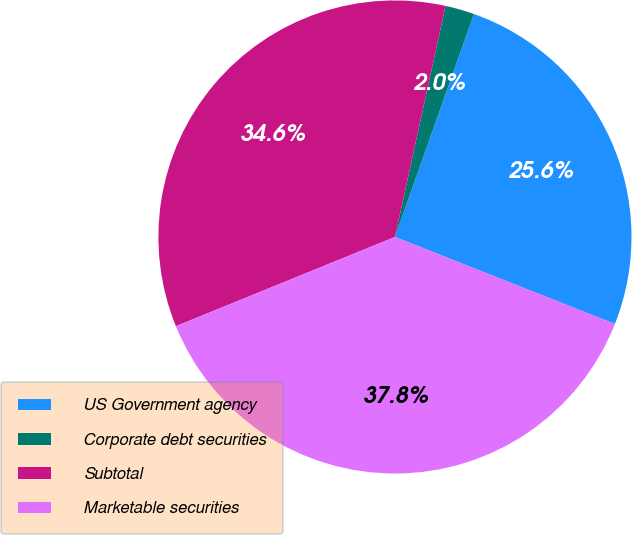Convert chart to OTSL. <chart><loc_0><loc_0><loc_500><loc_500><pie_chart><fcel>US Government agency<fcel>Corporate debt securities<fcel>Subtotal<fcel>Marketable securities<nl><fcel>25.58%<fcel>1.99%<fcel>34.59%<fcel>37.85%<nl></chart> 